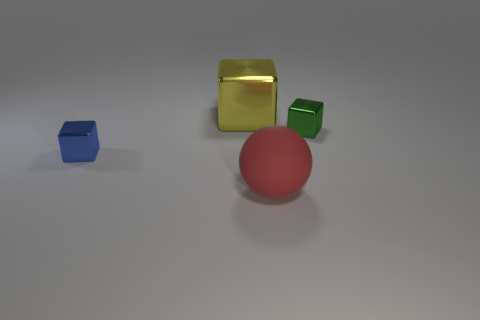Is there any other thing that has the same size as the yellow object?
Your answer should be very brief. Yes. There is a big yellow object; are there any big matte spheres in front of it?
Your answer should be compact. Yes. Is the color of the small metallic block that is to the right of the yellow shiny block the same as the cube that is left of the big yellow cube?
Your answer should be compact. No. Are there any tiny green metal objects that have the same shape as the tiny blue thing?
Ensure brevity in your answer.  Yes. What color is the tiny thing that is on the right side of the big object behind the small shiny object right of the big sphere?
Keep it short and to the point. Green. Are there the same number of blue objects that are behind the blue thing and red balls?
Provide a succinct answer. No. Is the size of the cube that is to the left of the yellow cube the same as the small green metallic cube?
Provide a succinct answer. Yes. What number of small blue metal things are there?
Your answer should be compact. 1. How many metal things are both left of the yellow shiny cube and to the right of the large red ball?
Provide a succinct answer. 0. Are there any tiny red blocks that have the same material as the blue cube?
Provide a short and direct response. No. 